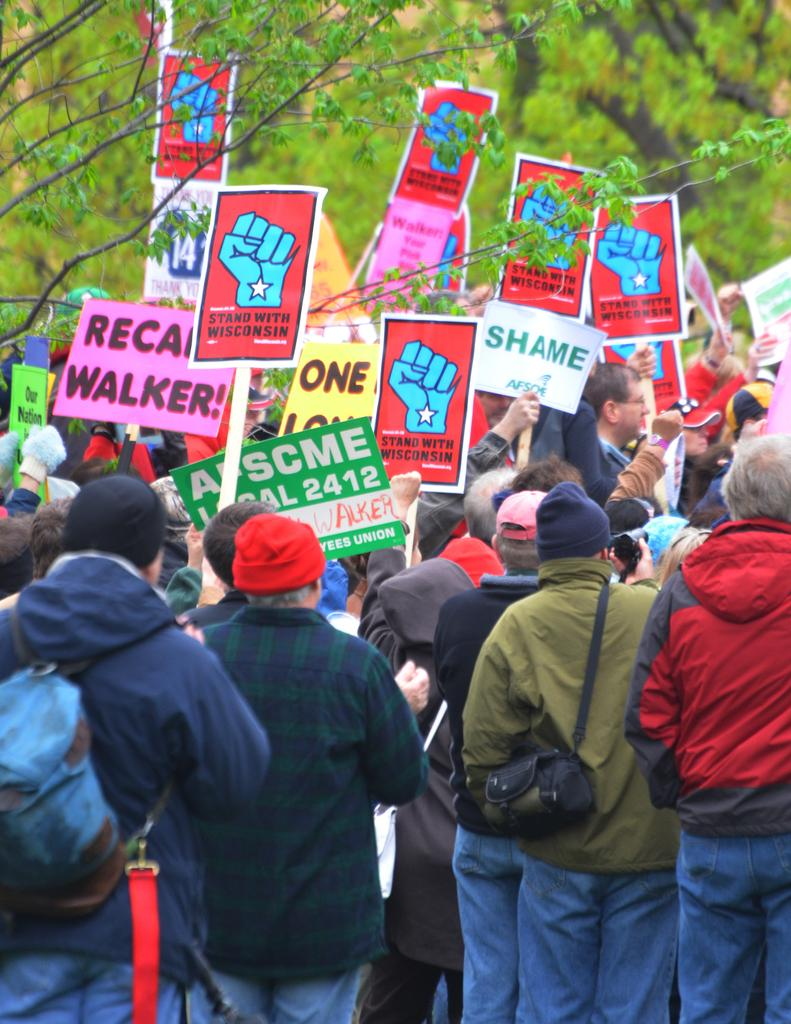What is happening in the image involving the group of people? The people are doing a strike, as they are standing and holding boards. What are the people holding in the image? The people are holding boards in the image. What can be seen in the background of the image? There are trees visible in the background of the image. What type of bottle is being shaken by the people in the image? There is no bottle present in the image, and the people are not shaking anything. 